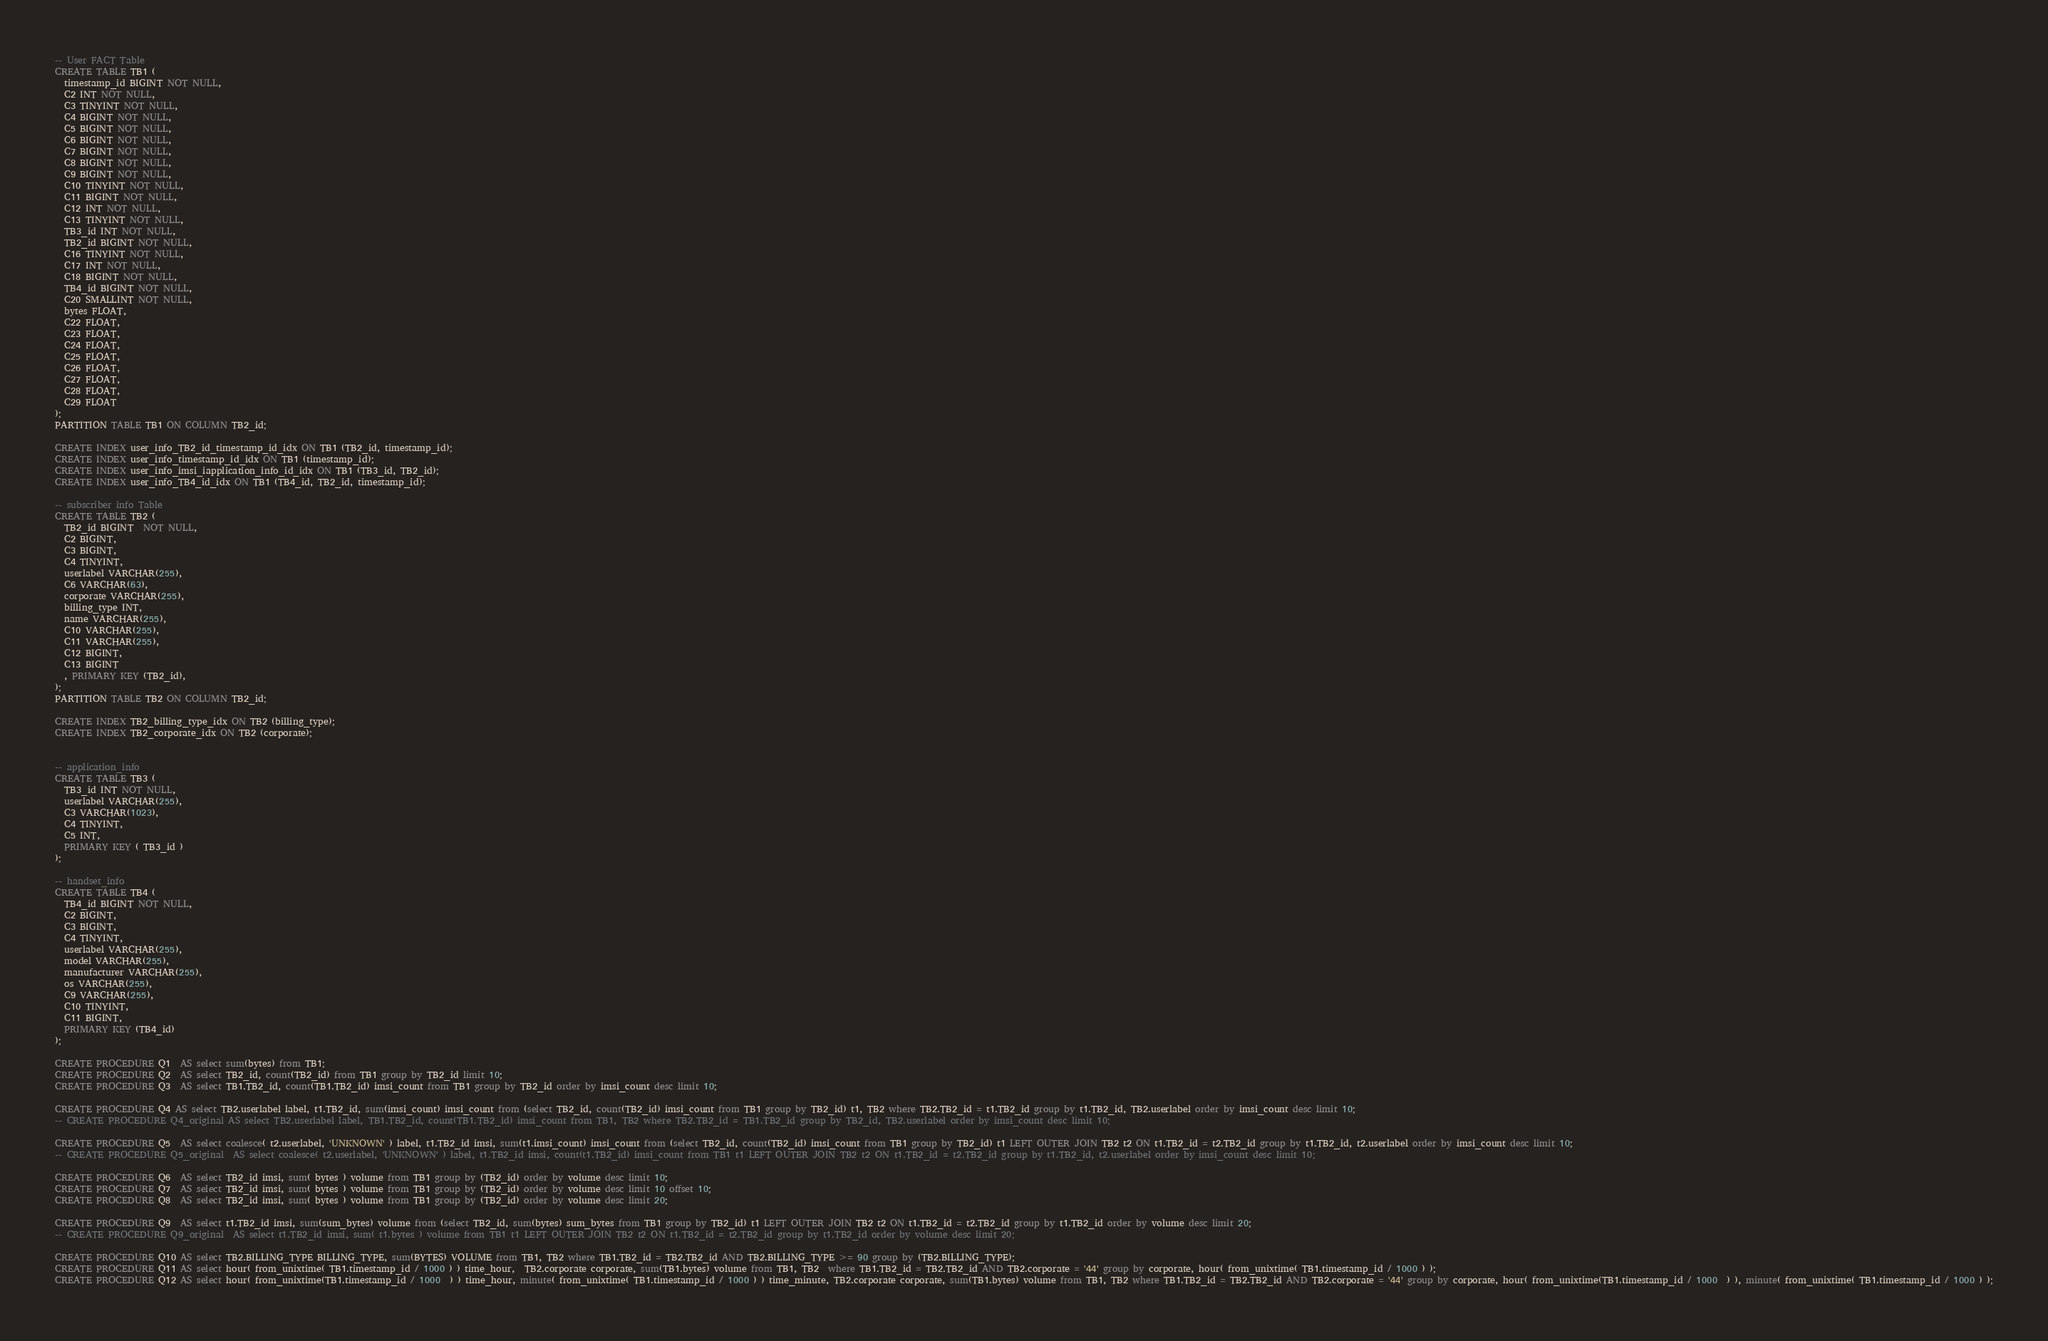<code> <loc_0><loc_0><loc_500><loc_500><_SQL_>-- User FACT Table
CREATE TABLE TB1 ( 
  timestamp_id BIGINT NOT NULL,               
  C2 INT NOT NULL,                     
  C3 TINYINT NOT NULL,              
  C4 BIGINT NOT NULL,                    
  C5 BIGINT NOT NULL,                 
  C6 BIGINT NOT NULL,                 
  C7 BIGINT NOT NULL,              
  C8 BIGINT NOT NULL,              
  C9 BIGINT NOT NULL,                    
  C10 TINYINT NOT NULL,                    
  C11 BIGINT NOT NULL,                     
  C12 INT NOT NULL,                   
  C13 TINYINT NOT NULL,             
  TB3_id INT NOT NULL,                
  TB2_id BIGINT NOT NULL,                    
  C16 TINYINT NOT NULL,              
  C17 INT NOT NULL,                   
  C18 BIGINT NOT NULL,                
  TB4_id BIGINT NOT NULL,                 
  C20 SMALLINT NOT NULL,               
  bytes FLOAT,                       
  C22 FLOAT,                        
  C23 FLOAT,                     
  C24 FLOAT,                  
  C25 FLOAT,                   
  C26 FLOAT,                
  C27 FLOAT,                 
  C28 FLOAT,                 
  C29 FLOAT             
);
PARTITION TABLE TB1 ON COLUMN TB2_id;

CREATE INDEX user_info_TB2_id_timestamp_id_idx ON TB1 (TB2_id, timestamp_id);
CREATE INDEX user_info_timestamp_id_idx ON TB1 (timestamp_id);
CREATE INDEX user_info_imsi_iapplication_info_id_idx ON TB1 (TB3_id, TB2_id);
CREATE INDEX user_info_TB4_id_idx ON TB1 (TB4_id, TB2_id, timestamp_id);

-- subscriber info Table
CREATE TABLE TB2 (
  TB2_id BIGINT  NOT NULL,                                 
  C2 BIGINT,                              
  C3 BIGINT,                                
  C4 TINYINT,                             
  userlabel VARCHAR(255),                               
  C6 VARCHAR(63),                                  
  corporate VARCHAR(255),                               
  billing_type INT,                               
  name VARCHAR(255),                                    
  C10 VARCHAR(255),                                  
  C11 VARCHAR(255),                                    
  C12 BIGINT,                        
  C13 BIGINT  
  , PRIMARY KEY (TB2_id),                            
);
PARTITION TABLE TB2 ON COLUMN TB2_id;

CREATE INDEX TB2_billing_type_idx ON TB2 (billing_type);
CREATE INDEX TB2_corporate_idx ON TB2 (corporate);


-- application_info
CREATE TABLE TB3 (
  TB3_id INT NOT NULL,
  userlabel VARCHAR(255),
  C3 VARCHAR(1023),
  C4 TINYINT,
  C5 INT,
  PRIMARY KEY ( TB3_id )
);

-- handset_info
CREATE TABLE TB4 (
  TB4_id BIGINT NOT NULL,
  C2 BIGINT,
  C3 BIGINT,
  C4 TINYINT,
  userlabel VARCHAR(255),
  model VARCHAR(255),
  manufacturer VARCHAR(255),
  os VARCHAR(255),
  C9 VARCHAR(255),
  C10 TINYINT,
  C11 BIGINT,
  PRIMARY KEY (TB4_id)
);

CREATE PROCEDURE Q1  AS select sum(bytes) from TB1;
CREATE PROCEDURE Q2  AS select TB2_id, count(TB2_id) from TB1 group by TB2_id limit 10;
CREATE PROCEDURE Q3  AS select TB1.TB2_id, count(TB1.TB2_id) imsi_count from TB1 group by TB2_id order by imsi_count desc limit 10;

CREATE PROCEDURE Q4 AS select TB2.userlabel label, t1.TB2_id, sum(imsi_count) imsi_count from (select TB2_id, count(TB2_id) imsi_count from TB1 group by TB2_id) t1, TB2 where TB2.TB2_id = t1.TB2_id group by t1.TB2_id, TB2.userlabel order by imsi_count desc limit 10;
-- CREATE PROCEDURE Q4_original AS select TB2.userlabel label, TB1.TB2_id, count(TB1.TB2_id) imsi_count from TB1, TB2 where TB2.TB2_id = TB1.TB2_id group by TB2_id, TB2.userlabel order by imsi_count desc limit 10;

CREATE PROCEDURE Q5  AS select coalesce( t2.userlabel, 'UNKNOWN' ) label, t1.TB2_id imsi, sum(t1.imsi_count) imsi_count from (select TB2_id, count(TB2_id) imsi_count from TB1 group by TB2_id) t1 LEFT OUTER JOIN TB2 t2 ON t1.TB2_id = t2.TB2_id group by t1.TB2_id, t2.userlabel order by imsi_count desc limit 10;
-- CREATE PROCEDURE Q5_original  AS select coalesce( t2.userlabel, 'UNKNOWN' ) label, t1.TB2_id imsi, count(t1.TB2_id) imsi_count from TB1 t1 LEFT OUTER JOIN TB2 t2 ON t1.TB2_id = t2.TB2_id group by t1.TB2_id, t2.userlabel order by imsi_count desc limit 10;

CREATE PROCEDURE Q6  AS select TB2_id imsi, sum( bytes ) volume from TB1 group by (TB2_id) order by volume desc limit 10;
CREATE PROCEDURE Q7  AS select TB2_id imsi, sum( bytes ) volume from TB1 group by (TB2_id) order by volume desc limit 10 offset 10;
CREATE PROCEDURE Q8  AS select TB2_id imsi, sum( bytes ) volume from TB1 group by (TB2_id) order by volume desc limit 20;

CREATE PROCEDURE Q9  AS select t1.TB2_id imsi, sum(sum_bytes) volume from (select TB2_id, sum(bytes) sum_bytes from TB1 group by TB2_id) t1 LEFT OUTER JOIN TB2 t2 ON t1.TB2_id = t2.TB2_id group by t1.TB2_id order by volume desc limit 20;
-- CREATE PROCEDURE Q9_original  AS select t1.TB2_id imsi, sum( t1.bytes ) volume from TB1 t1 LEFT OUTER JOIN TB2 t2 ON t1.TB2_id = t2.TB2_id group by t1.TB2_id order by volume desc limit 20;

CREATE PROCEDURE Q10 AS select TB2.BILLING_TYPE BILLING_TYPE, sum(BYTES) VOLUME from TB1, TB2 where TB1.TB2_id = TB2.TB2_id AND TB2.BILLING_TYPE >= 90 group by (TB2.BILLING_TYPE);
CREATE PROCEDURE Q11 AS select hour( from_unixtime( TB1.timestamp_id / 1000 ) ) time_hour,  TB2.corporate corporate, sum(TB1.bytes) volume from TB1, TB2  where TB1.TB2_id = TB2.TB2_id AND TB2.corporate = '44' group by corporate, hour( from_unixtime( TB1.timestamp_id / 1000 ) );
CREATE PROCEDURE Q12 AS select hour( from_unixtime(TB1.timestamp_id / 1000  ) ) time_hour, minute( from_unixtime( TB1.timestamp_id / 1000 ) ) time_minute, TB2.corporate corporate, sum(TB1.bytes) volume from TB1, TB2 where TB1.TB2_id = TB2.TB2_id AND TB2.corporate = '44' group by corporate, hour( from_unixtime(TB1.timestamp_id / 1000  ) ), minute( from_unixtime( TB1.timestamp_id / 1000 ) );
</code> 